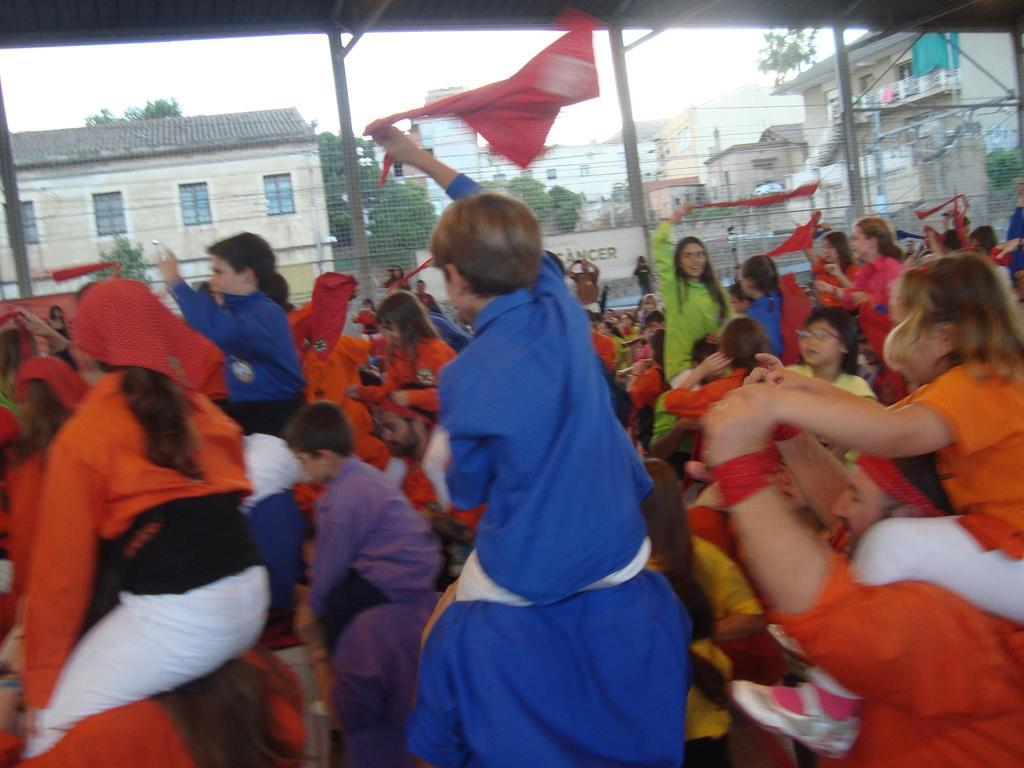How many people are present in the image? There are many people in the image. What are some people doing with their kids in the image? Some people have kids on their shoulders in the image. What can be observed about the clothing of the people in the image? The people are wearing colorful dresses in the image. What can be seen in the background of the image? There are houses and trees in the background of the image. How many water balloons are being thrown in the image? There is no water or balloons present in the image. Can you see a bike in the image? There is no bike visible in the image. 